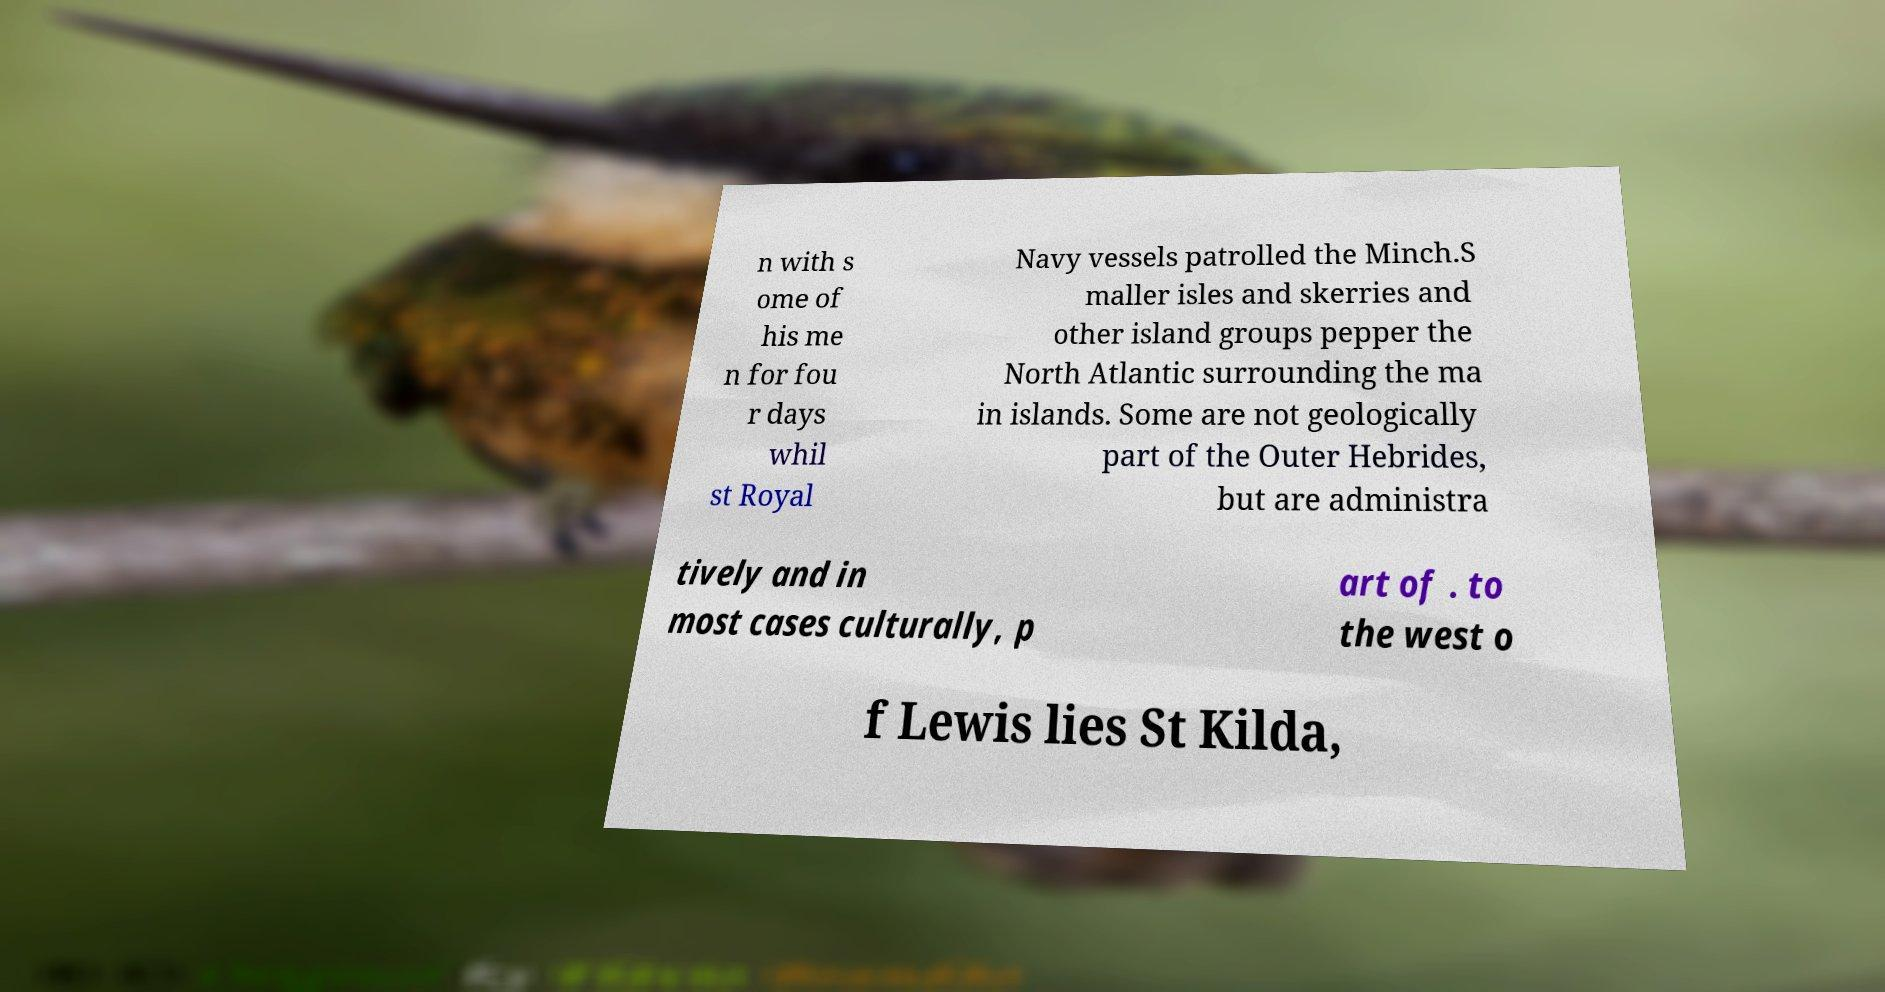Could you extract and type out the text from this image? n with s ome of his me n for fou r days whil st Royal Navy vessels patrolled the Minch.S maller isles and skerries and other island groups pepper the North Atlantic surrounding the ma in islands. Some are not geologically part of the Outer Hebrides, but are administra tively and in most cases culturally, p art of . to the west o f Lewis lies St Kilda, 